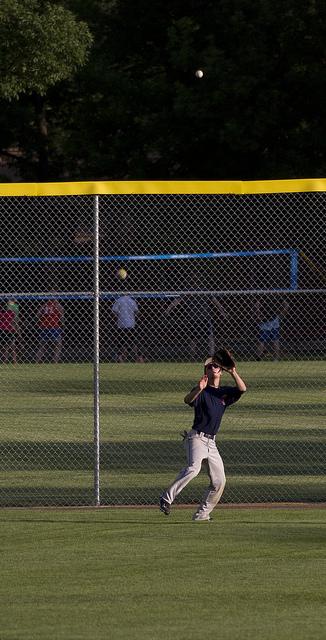Is he throwing a baseball?
Short answer required. No. What is the man wearing on his hand?
Quick response, please. Glove. Is this man playing baseball?
Keep it brief. Yes. 